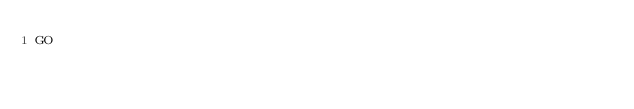Convert code to text. <code><loc_0><loc_0><loc_500><loc_500><_SQL_>GO
</code> 